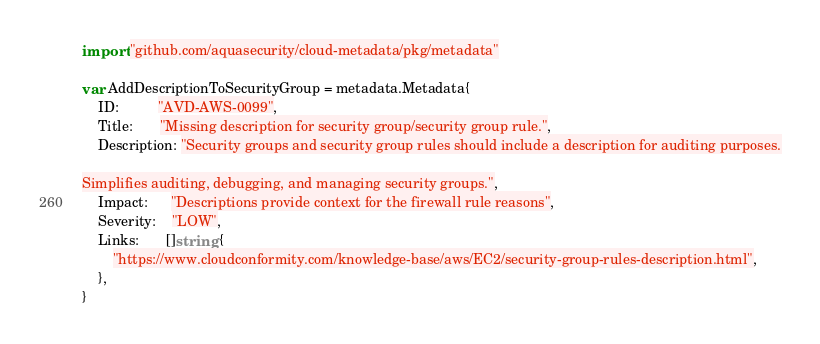Convert code to text. <code><loc_0><loc_0><loc_500><loc_500><_Go_>import "github.com/aquasecurity/cloud-metadata/pkg/metadata"

var AddDescriptionToSecurityGroup = metadata.Metadata{
	ID:          "AVD-AWS-0099",
	Title:       "Missing description for security group/security group rule.",
	Description: "Security groups and security group rules should include a description for auditing purposes.

Simplifies auditing, debugging, and managing security groups.",
	Impact:      "Descriptions provide context for the firewall rule reasons",
	Severity:    "LOW",
	Links:       []string {
		"https://www.cloudconformity.com/knowledge-base/aws/EC2/security-group-rules-description.html", 
	},
}

</code> 